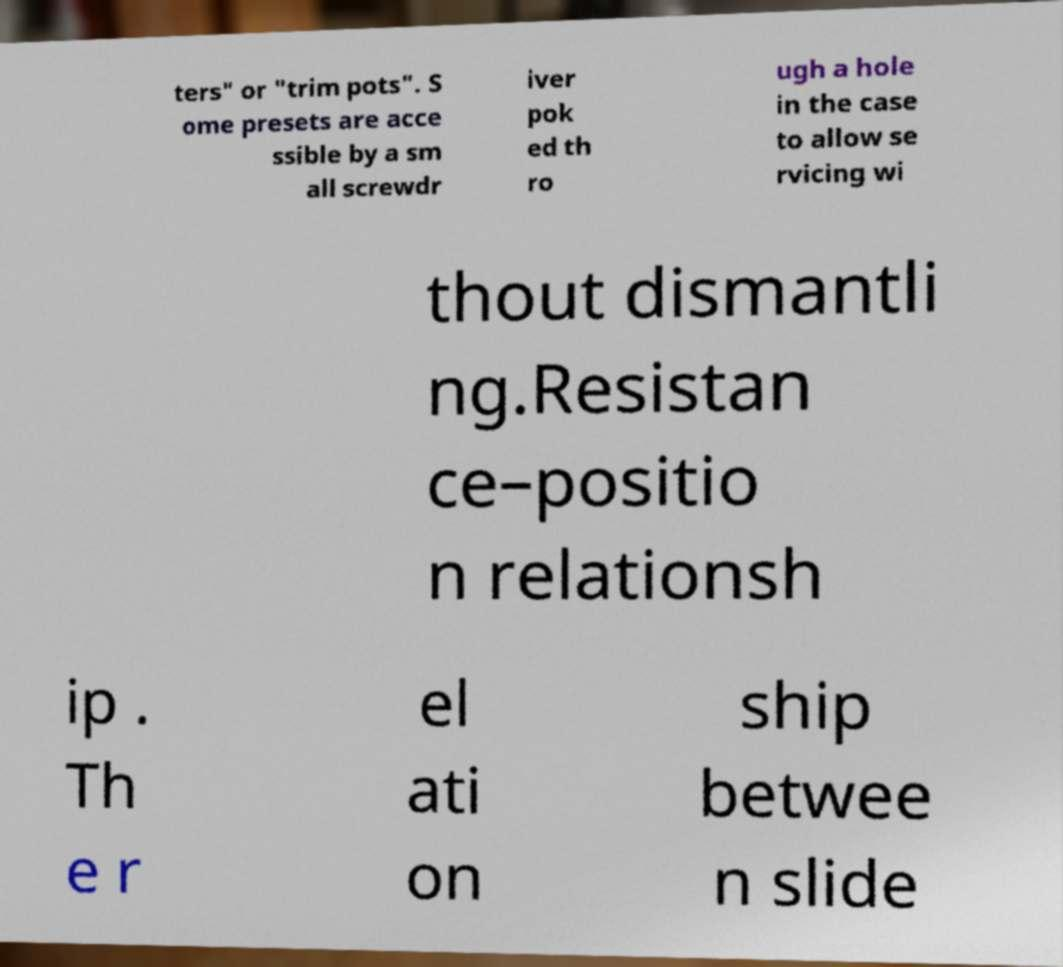I need the written content from this picture converted into text. Can you do that? ters" or "trim pots". S ome presets are acce ssible by a sm all screwdr iver pok ed th ro ugh a hole in the case to allow se rvicing wi thout dismantli ng.Resistan ce–positio n relationsh ip . Th e r el ati on ship betwee n slide 